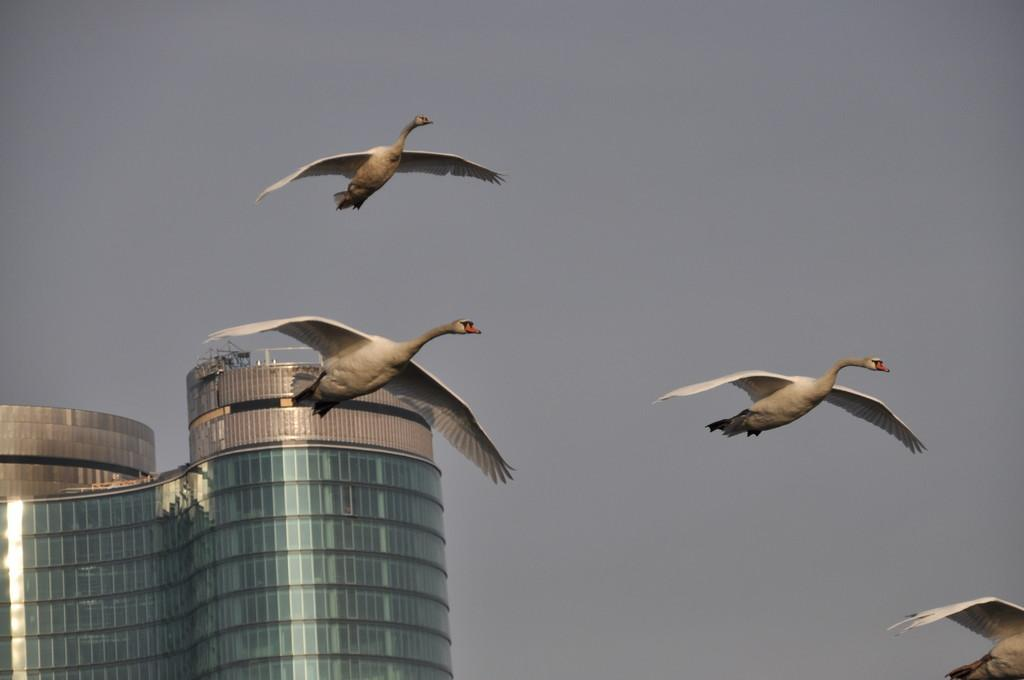What is happening in the sky in the image? There are birds flying in the sky in the image. In which direction are the birds flying? The birds are flying towards the right in the image. What can be seen at the bottom left of the image? There is a building at the bottom left of the image. What is visible in the background of the image? The sky is visible in the background of the image. What type of channel can be seen in the image? There is no channel present in the image; it features birds flying in the sky and a building at the bottom left. What reward is the bird receiving for flying in the image? There is no reward being given to the birds in the image; they are simply flying in the sky. 